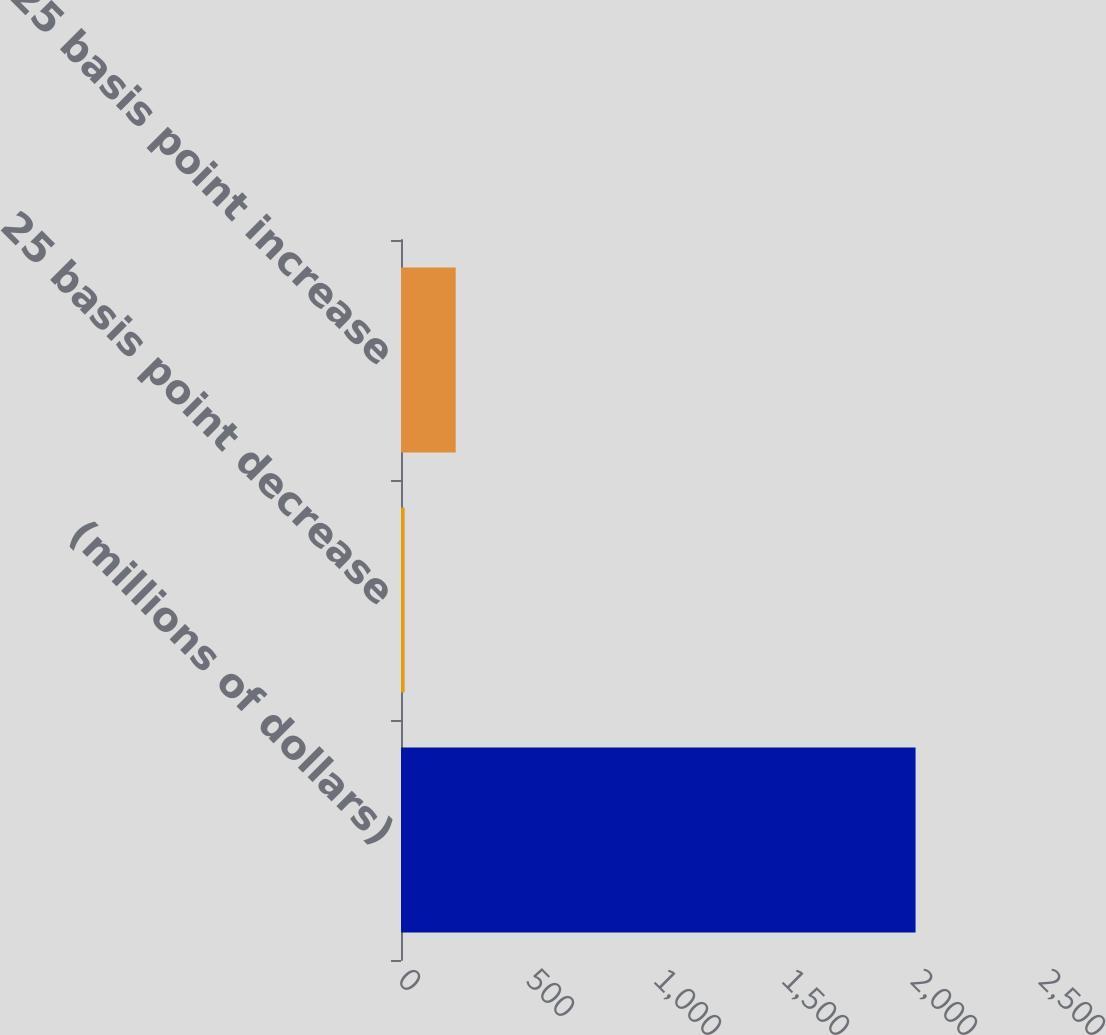Convert chart to OTSL. <chart><loc_0><loc_0><loc_500><loc_500><bar_chart><fcel>(millions of dollars)<fcel>25 basis point decrease<fcel>25 basis point increase<nl><fcel>2010<fcel>14.1<fcel>213.69<nl></chart> 